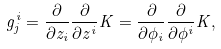Convert formula to latex. <formula><loc_0><loc_0><loc_500><loc_500>g _ { j } ^ { i } = \frac { \partial } { \partial z _ { i } } \frac { \partial } { \partial z ^ { i } } K = \frac { \partial } { \partial \phi _ { i } } \frac { \partial } { \partial \phi ^ { i } } K ,</formula> 